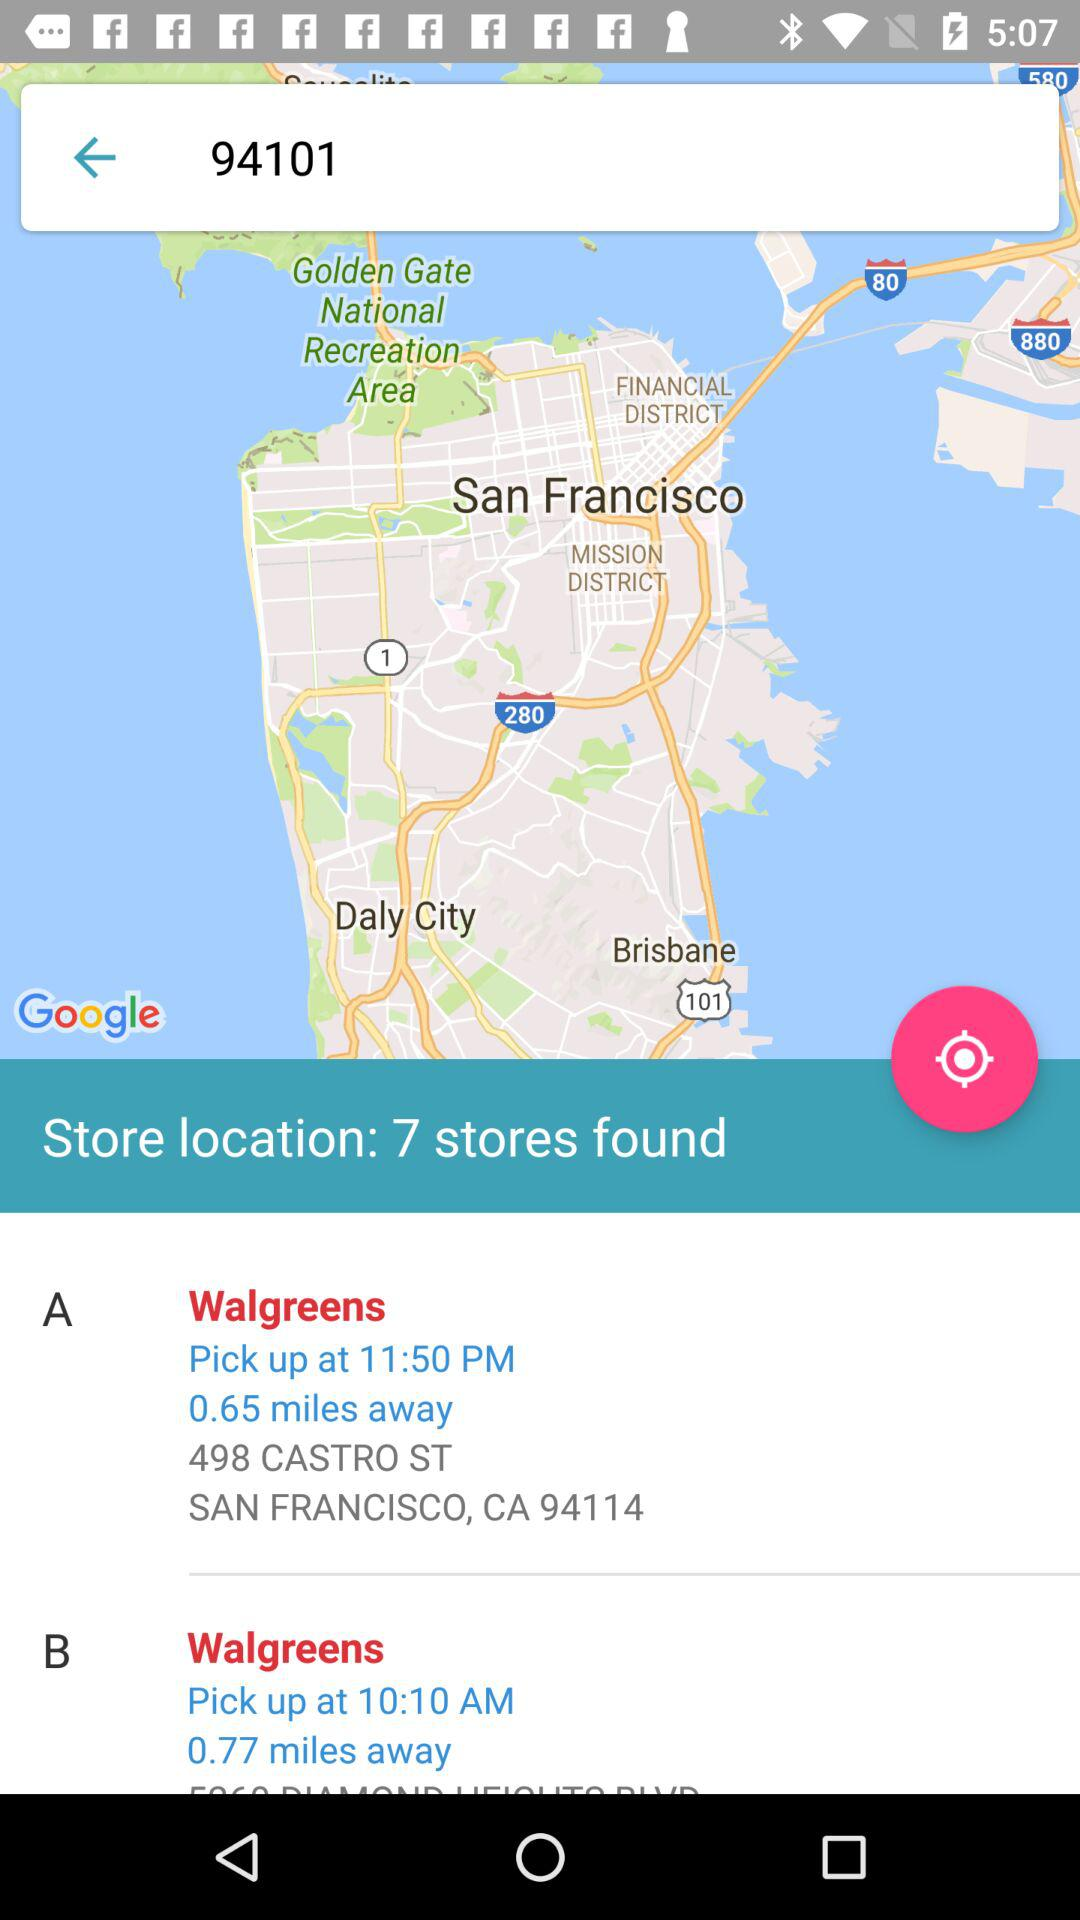What is the distance to the Walgreens-A? Walgreens-A is at a distance of 0.65 miles away. 